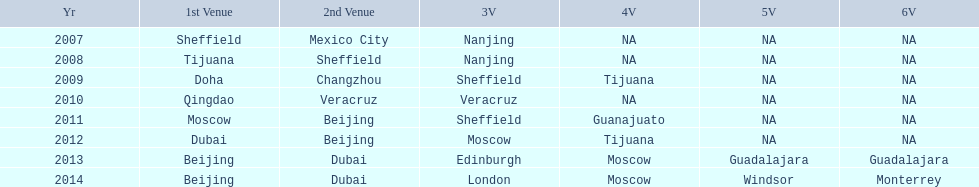Name a year whose second venue was the same as 2011. 2012. 